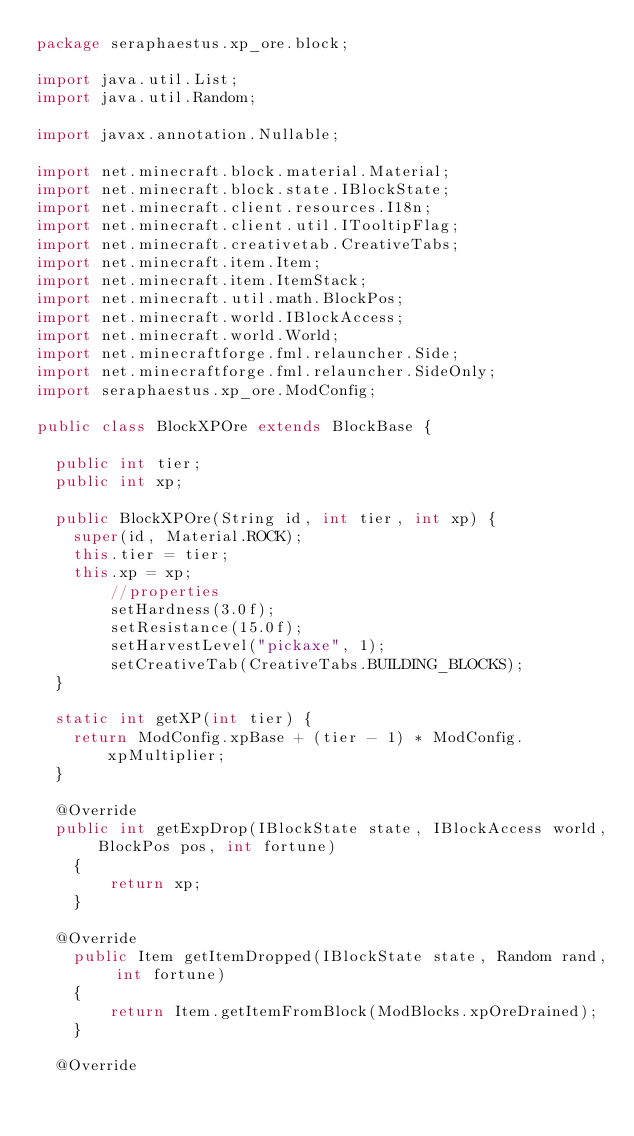Convert code to text. <code><loc_0><loc_0><loc_500><loc_500><_Java_>package seraphaestus.xp_ore.block;

import java.util.List;
import java.util.Random;

import javax.annotation.Nullable;

import net.minecraft.block.material.Material;
import net.minecraft.block.state.IBlockState;
import net.minecraft.client.resources.I18n;
import net.minecraft.client.util.ITooltipFlag;
import net.minecraft.creativetab.CreativeTabs;
import net.minecraft.item.Item;
import net.minecraft.item.ItemStack;
import net.minecraft.util.math.BlockPos;
import net.minecraft.world.IBlockAccess;
import net.minecraft.world.World;
import net.minecraftforge.fml.relauncher.Side;
import net.minecraftforge.fml.relauncher.SideOnly;
import seraphaestus.xp_ore.ModConfig;

public class BlockXPOre extends BlockBase {

	public int tier;
	public int xp;
	
	public BlockXPOre(String id, int tier, int xp) {
		super(id, Material.ROCK);
		this.tier = tier;
		this.xp = xp;
        //properties
        setHardness(3.0f);
        setResistance(15.0f);
        setHarvestLevel("pickaxe", 1);
        setCreativeTab(CreativeTabs.BUILDING_BLOCKS);
	}
	
	static int getXP(int tier) {
		return ModConfig.xpBase + (tier - 1) * ModConfig.xpMultiplier;
	}
	
	@Override
	public int getExpDrop(IBlockState state, IBlockAccess world, BlockPos pos, int fortune)
    {
        return xp;
    }
	
	@Override
    public Item getItemDropped(IBlockState state, Random rand, int fortune)
    {
        return Item.getItemFromBlock(ModBlocks.xpOreDrained);
    }
	
	@Override</code> 